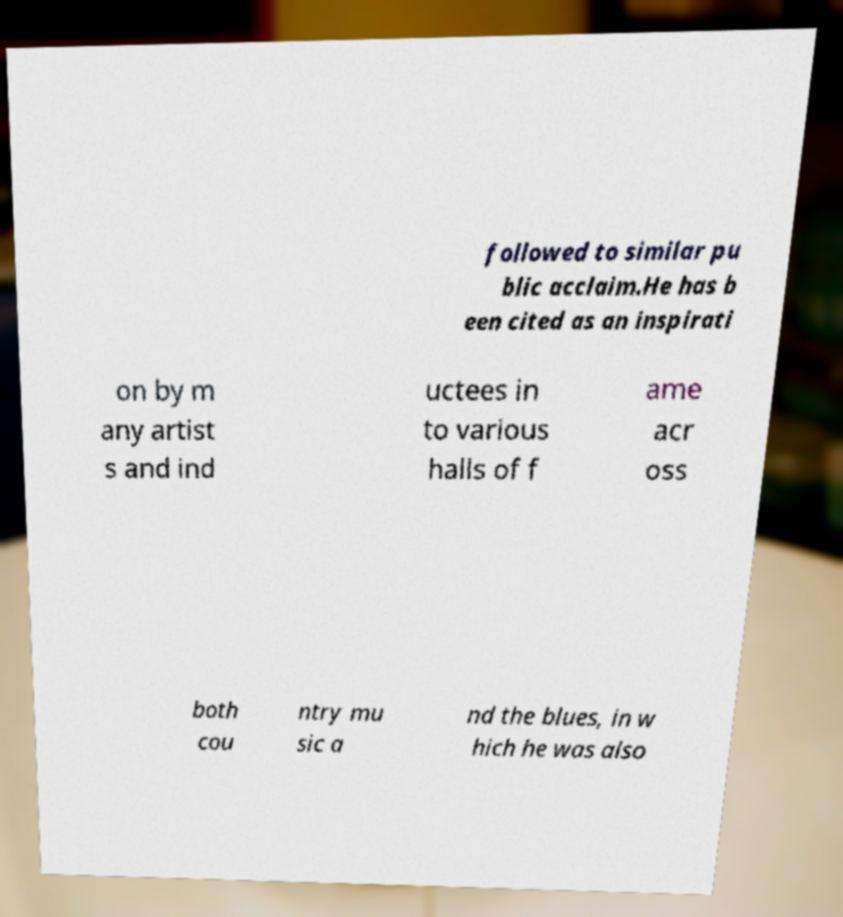Could you extract and type out the text from this image? followed to similar pu blic acclaim.He has b een cited as an inspirati on by m any artist s and ind uctees in to various halls of f ame acr oss both cou ntry mu sic a nd the blues, in w hich he was also 